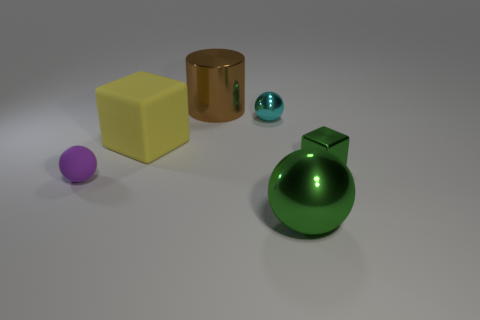What shape is the green object that is the same size as the brown thing?
Provide a short and direct response. Sphere. There is a block right of the large metallic thing right of the big brown thing; how many big matte cubes are in front of it?
Offer a very short reply. 0. What number of matte objects are either tiny balls or big things?
Your answer should be very brief. 2. There is a sphere that is both left of the green sphere and in front of the yellow cube; what is its color?
Give a very brief answer. Purple. Do the block in front of the rubber block and the big cylinder have the same size?
Keep it short and to the point. No. How many objects are large things that are behind the tiny purple rubber object or large metallic balls?
Provide a short and direct response. 3. Is there a cyan shiny sphere of the same size as the purple matte ball?
Provide a short and direct response. Yes. What is the material of the cyan thing that is the same size as the green shiny block?
Offer a very short reply. Metal. The big object that is both in front of the large brown object and on the left side of the big green shiny thing has what shape?
Provide a succinct answer. Cube. There is a thing behind the tiny shiny sphere; what is its color?
Make the answer very short. Brown. 